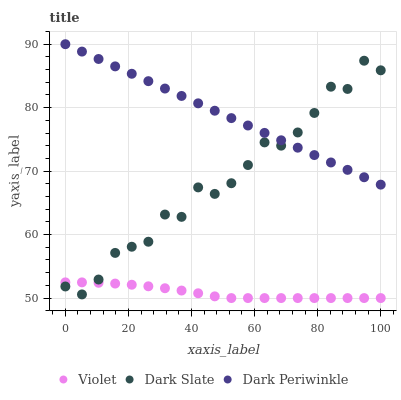Does Violet have the minimum area under the curve?
Answer yes or no. Yes. Does Dark Periwinkle have the maximum area under the curve?
Answer yes or no. Yes. Does Dark Periwinkle have the minimum area under the curve?
Answer yes or no. No. Does Violet have the maximum area under the curve?
Answer yes or no. No. Is Dark Periwinkle the smoothest?
Answer yes or no. Yes. Is Dark Slate the roughest?
Answer yes or no. Yes. Is Violet the smoothest?
Answer yes or no. No. Is Violet the roughest?
Answer yes or no. No. Does Violet have the lowest value?
Answer yes or no. Yes. Does Dark Periwinkle have the lowest value?
Answer yes or no. No. Does Dark Periwinkle have the highest value?
Answer yes or no. Yes. Does Violet have the highest value?
Answer yes or no. No. Is Violet less than Dark Periwinkle?
Answer yes or no. Yes. Is Dark Periwinkle greater than Violet?
Answer yes or no. Yes. Does Dark Slate intersect Dark Periwinkle?
Answer yes or no. Yes. Is Dark Slate less than Dark Periwinkle?
Answer yes or no. No. Is Dark Slate greater than Dark Periwinkle?
Answer yes or no. No. Does Violet intersect Dark Periwinkle?
Answer yes or no. No. 